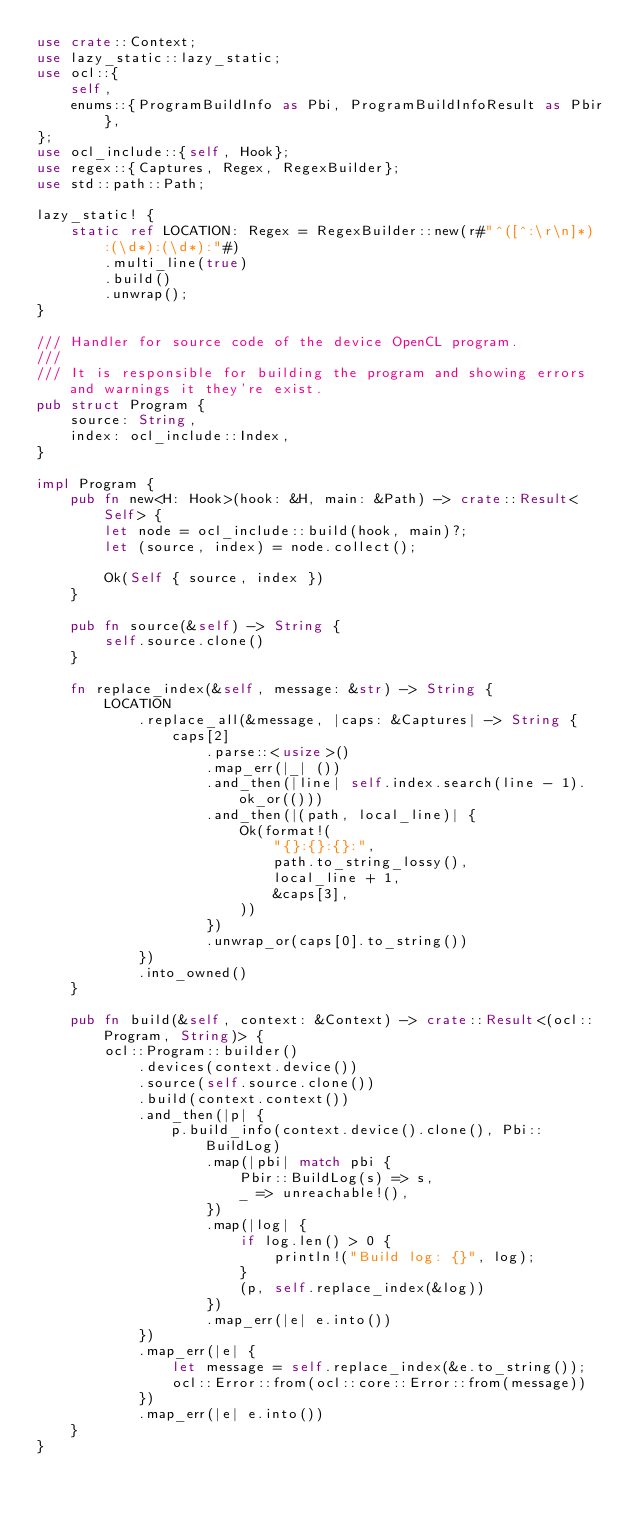Convert code to text. <code><loc_0><loc_0><loc_500><loc_500><_Rust_>use crate::Context;
use lazy_static::lazy_static;
use ocl::{
    self,
    enums::{ProgramBuildInfo as Pbi, ProgramBuildInfoResult as Pbir},
};
use ocl_include::{self, Hook};
use regex::{Captures, Regex, RegexBuilder};
use std::path::Path;

lazy_static! {
    static ref LOCATION: Regex = RegexBuilder::new(r#"^([^:\r\n]*):(\d*):(\d*):"#)
        .multi_line(true)
        .build()
        .unwrap();
}

/// Handler for source code of the device OpenCL program.
///
/// It is responsible for building the program and showing errors and warnings it they're exist.
pub struct Program {
    source: String,
    index: ocl_include::Index,
}

impl Program {
    pub fn new<H: Hook>(hook: &H, main: &Path) -> crate::Result<Self> {
        let node = ocl_include::build(hook, main)?;
        let (source, index) = node.collect();

        Ok(Self { source, index })
    }

    pub fn source(&self) -> String {
        self.source.clone()
    }

    fn replace_index(&self, message: &str) -> String {
        LOCATION
            .replace_all(&message, |caps: &Captures| -> String {
                caps[2]
                    .parse::<usize>()
                    .map_err(|_| ())
                    .and_then(|line| self.index.search(line - 1).ok_or(()))
                    .and_then(|(path, local_line)| {
                        Ok(format!(
                            "{}:{}:{}:",
                            path.to_string_lossy(),
                            local_line + 1,
                            &caps[3],
                        ))
                    })
                    .unwrap_or(caps[0].to_string())
            })
            .into_owned()
    }

    pub fn build(&self, context: &Context) -> crate::Result<(ocl::Program, String)> {
        ocl::Program::builder()
            .devices(context.device())
            .source(self.source.clone())
            .build(context.context())
            .and_then(|p| {
                p.build_info(context.device().clone(), Pbi::BuildLog)
                    .map(|pbi| match pbi {
                        Pbir::BuildLog(s) => s,
                        _ => unreachable!(),
                    })
                    .map(|log| {
                        if log.len() > 0 {
                            println!("Build log: {}", log);
                        }
                        (p, self.replace_index(&log))
                    })
                    .map_err(|e| e.into())
            })
            .map_err(|e| {
                let message = self.replace_index(&e.to_string());
                ocl::Error::from(ocl::core::Error::from(message))
            })
            .map_err(|e| e.into())
    }
}
</code> 